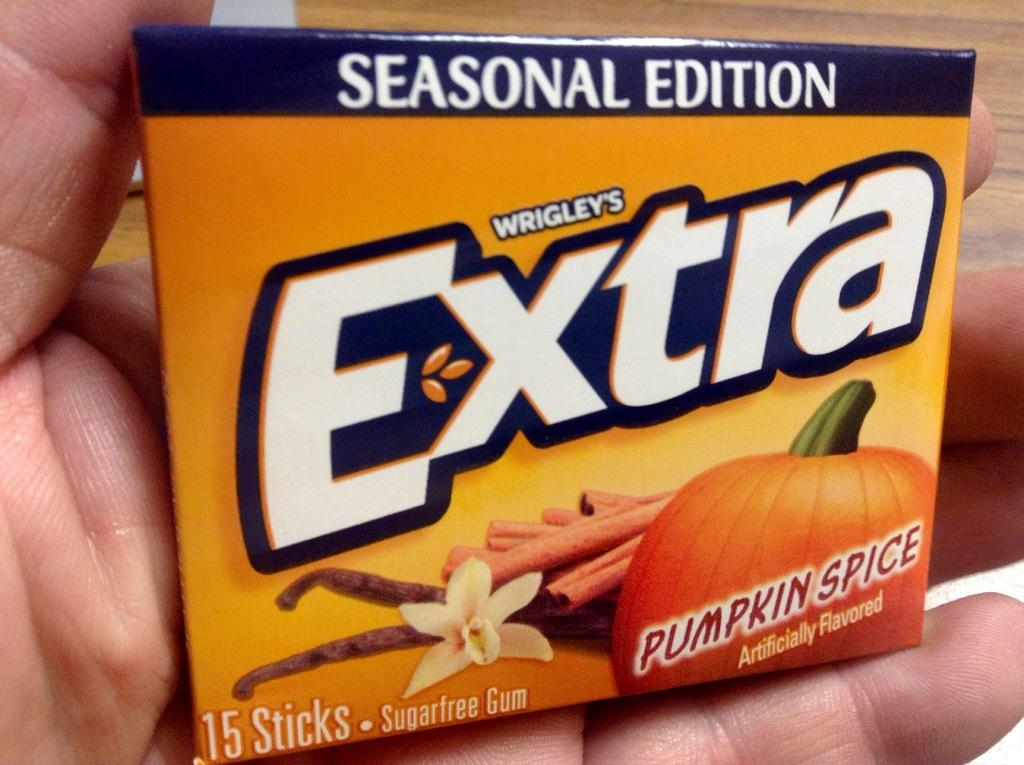<image>
Describe the image concisely. Pack of Wrigley's  extra gum  sugar-free in the seasonal edition flavor of pumpkin spice. 